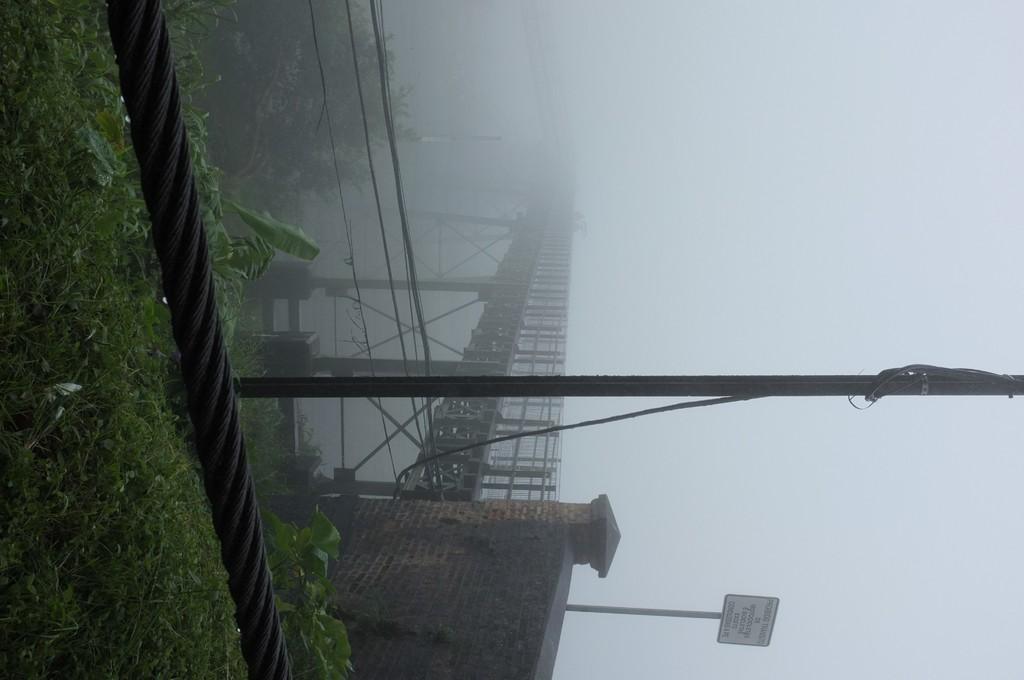In one or two sentences, can you explain what this image depicts? In the image we can see the grass, rope and the pole. Here we can see the bridge, wall, board and text on the board. Here we can see plants and foggy sky. 